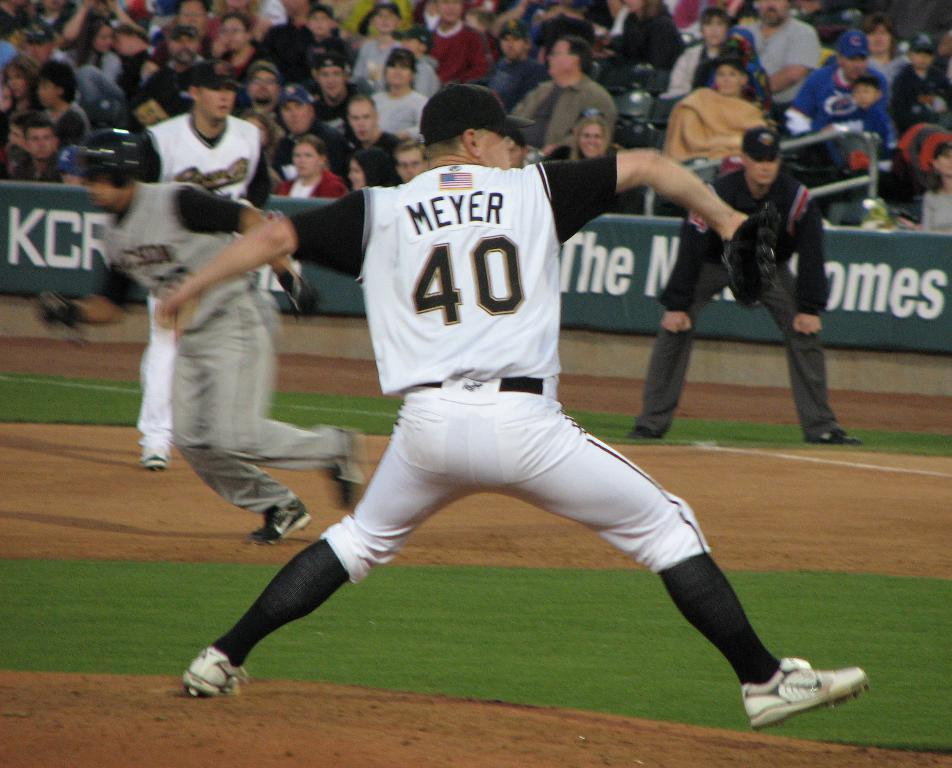<image>
Share a concise interpretation of the image provided. A baseball pitcher called Meyer and numbered 48 throws a ball as runners scamper in the background in an action packed shot. 